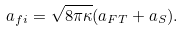Convert formula to latex. <formula><loc_0><loc_0><loc_500><loc_500>a _ { f i } = \sqrt { 8 \pi \kappa } ( a _ { F T } + a _ { S } ) .</formula> 